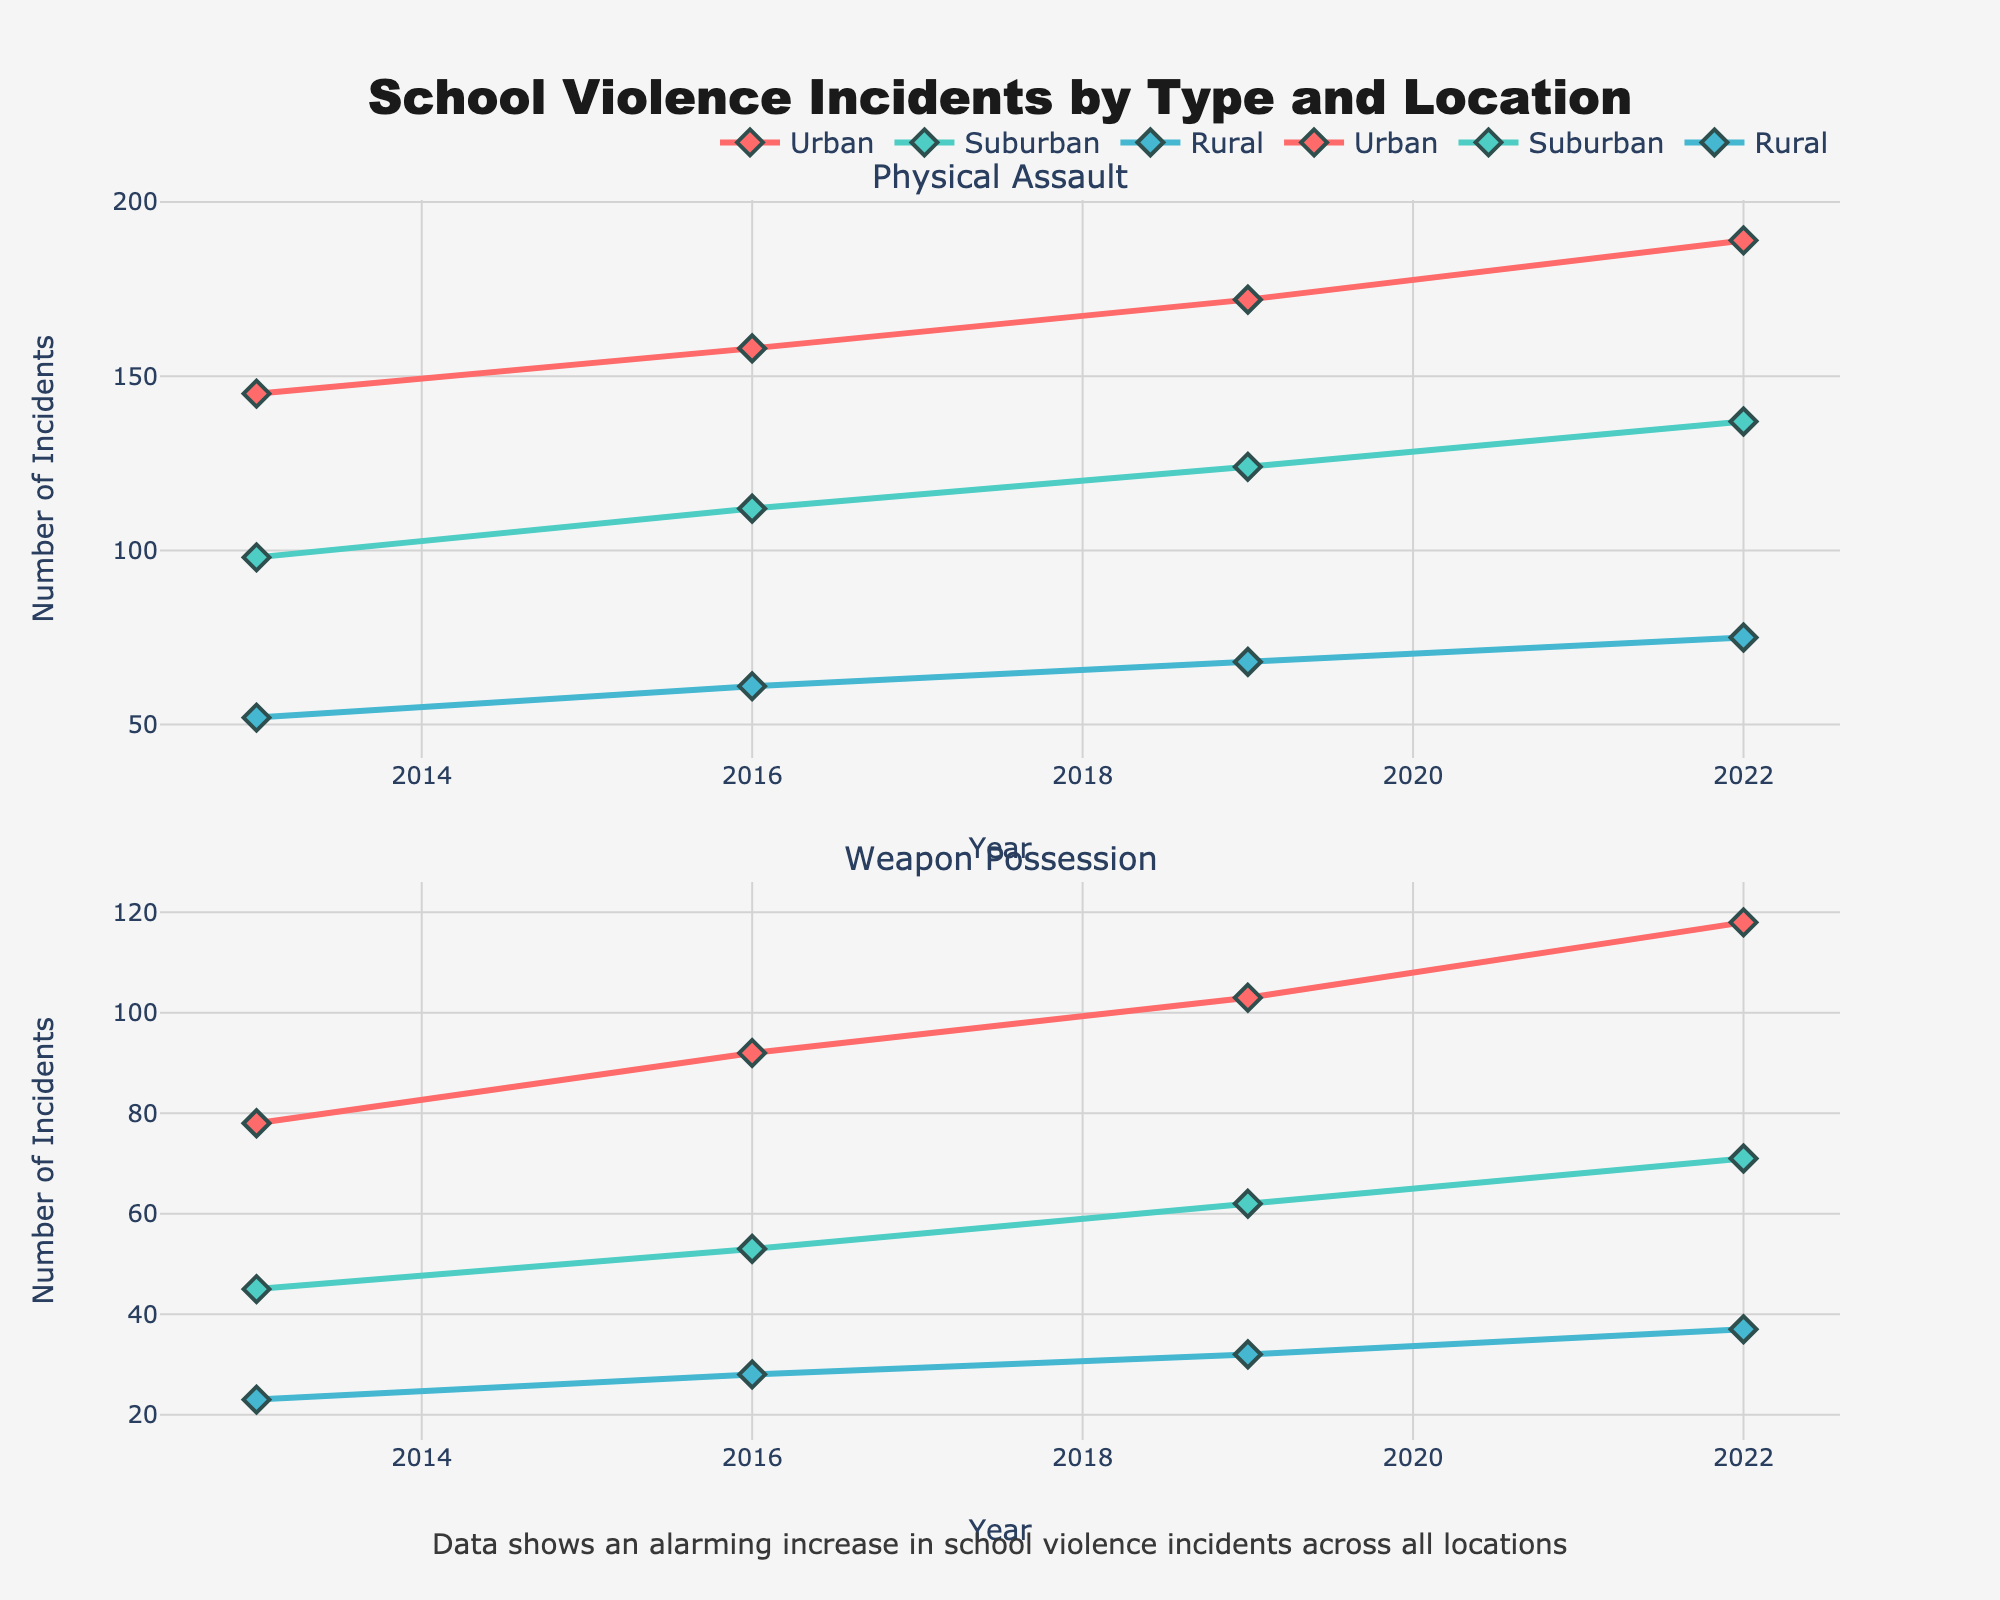What is the total Facebook engagement for all clubs? Sum the engagement values from the Facebook subplot. 620000 (FC Barcelona) + 210000 (Atlético Madrid) + 190000 (Real Madrid) + 95000 (Real Sociedad) + 70000 (Levante UD) = 1,185,000
Answer: 1,185,000 Which club has the highest Twitter engagement? Look at the Twitter subplot and identify the club with the highest bar. FC Barcelona has the highest engagement with 985,000.
Answer: FC Barcelona What is the difference in YouTube engagement between FC Barcelona and Real Madrid? Subtract the YouTube engagement of Real Madrid from FC Barcelona. 180,000 (FC Barcelona) - 75,000 (Real Madrid) = 105,000
Answer: 105,000 How does Atlético Madrid's TikTok engagement compare to Levante UD's Instagram engagement? Check the TikTok subplot for Atlético Madrid's engagement and the Instagram subplot for Levante UD's engagement. Atlético Madrid TikTok: 150,000, Levante UD Instagram: 95,000. Atlético Madrid has higher engagement.
Answer: Atlético Madrid has higher engagement Which club has the lowest engagement on Instagram? Look at the Instagram subplot and find the club with the smallest bar. Levante UD has the lowest engagement with 95,000.
Answer: Levante UD What is the average engagement across all platforms for Real Sociedad? Calculate the average using Real Sociedad's engagement on all platforms. (150,000 + 130,000 + 95,000 + 40,000 + 60,000) / 5 = 95,000
Answer: 95,000 On which platform does Levante UD have its highest engagement? Check all subplots for Levante UD and identify the highest value. Levante UD's Twitter engagement is the highest at 110,000.
Answer: Twitter How much higher is FC Barcelona's Instagram engagement compared to Real Madrid's Instagram engagement? Subtract Real Madrid's Instagram engagement from FC Barcelona's Instagram engagement. 750,000 (FC Barcelona) - 240,000 (Real Madrid) = 510,000
Answer: 510,000 Which two clubs have the closest engagement values on Facebook? Compare the Facebook engagement values and find the two closest. Atlético Madrid (210,000) and Real Madrid (190,000) are the closest with a difference of 20,000.
Answer: Atlético Madrid and Real Madrid What is the combined YouTube engagement for Atlético Madrid and Real Sociedad? Add the YouTube engagement values for both clubs. 90,000 (Atlético Madrid) + 40,000 (Real Sociedad) = 130,000
Answer: 130,000 